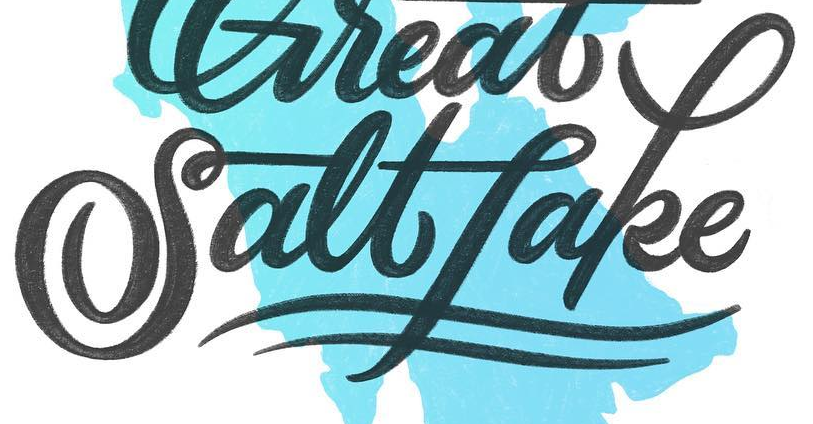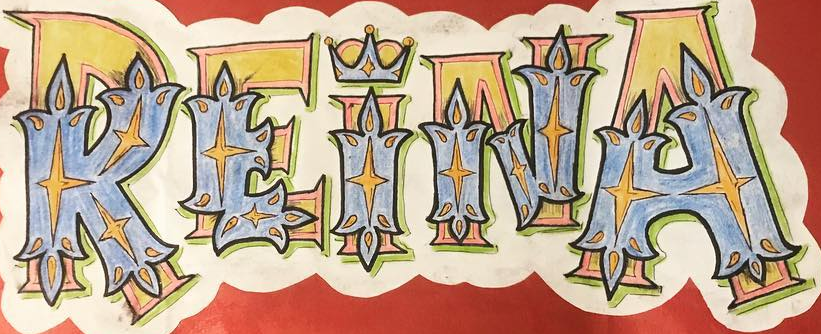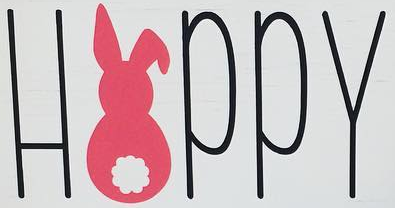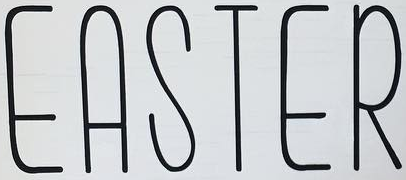Read the text content from these images in order, separated by a semicolon. Saltfake; REINA; HAPPY; EASTER 